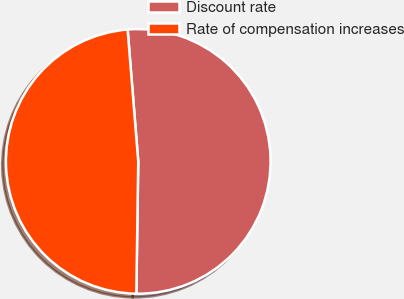<chart> <loc_0><loc_0><loc_500><loc_500><pie_chart><fcel>Discount rate<fcel>Rate of compensation increases<nl><fcel>51.51%<fcel>48.49%<nl></chart> 